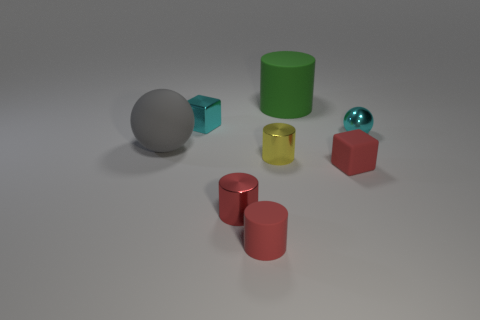What material is the green cylinder?
Keep it short and to the point. Rubber. There is a rubber thing in front of the small rubber thing that is behind the red matte cylinder; what is its shape?
Give a very brief answer. Cylinder. There is a tiny cyan metal object that is on the right side of the small cyan block; what is its shape?
Your answer should be compact. Sphere. What number of objects are the same color as the large matte ball?
Provide a succinct answer. 0. What is the color of the big sphere?
Ensure brevity in your answer.  Gray. What number of blocks are behind the ball that is behind the gray matte thing?
Your response must be concise. 1. Is the size of the gray thing the same as the rubber cylinder that is behind the small shiny block?
Your response must be concise. Yes. Do the green cylinder and the matte sphere have the same size?
Provide a succinct answer. Yes. Is there a green rubber thing that has the same size as the gray rubber object?
Your response must be concise. Yes. What material is the cube behind the tiny yellow cylinder?
Provide a succinct answer. Metal. 